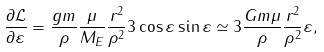Convert formula to latex. <formula><loc_0><loc_0><loc_500><loc_500>\frac { \partial \mathcal { L } } { \partial \varepsilon } = \frac { g m } { \rho } \frac { \mu } { M _ { E } } \frac { r ^ { 2 } } { { \rho } ^ { 2 } } 3 \cos { \varepsilon } \sin { \varepsilon } \simeq 3 \frac { G m \mu } { \rho } \frac { r ^ { 2 } } { { \rho } ^ { 2 } } \varepsilon ,</formula> 